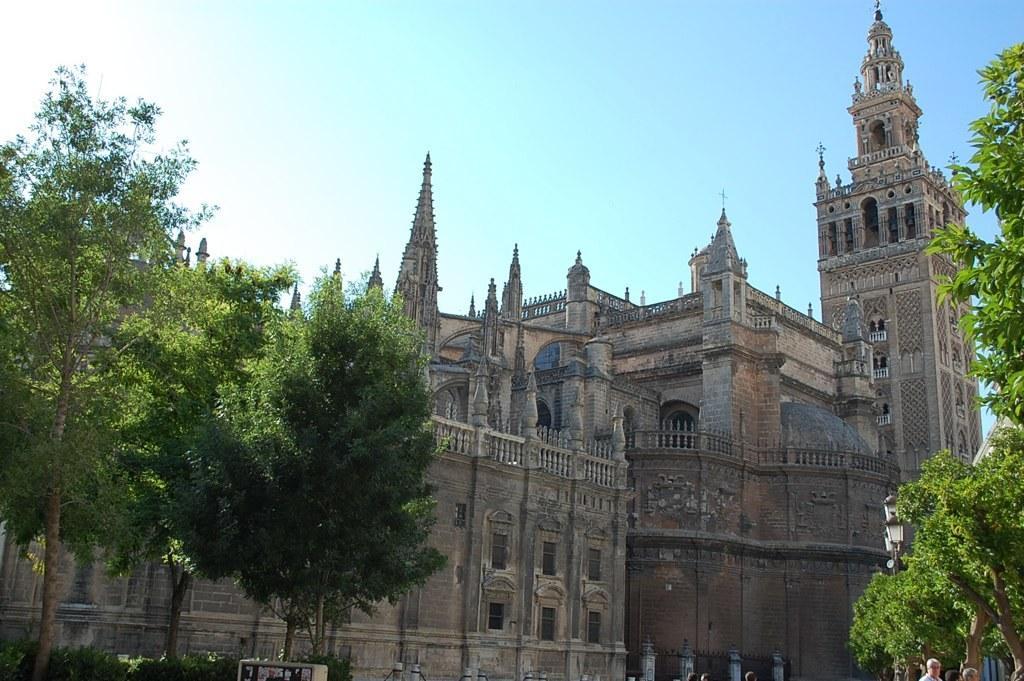Can you describe this image briefly? In this image I can see few trees which are green in color, few persons standing and few buildings which are brown, cream and black in color. In the background I can see the sky. 